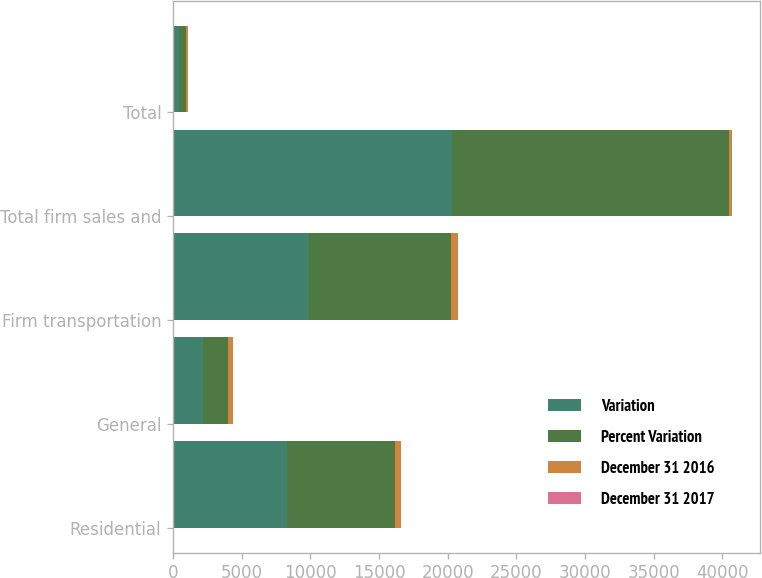Convert chart. <chart><loc_0><loc_0><loc_500><loc_500><stacked_bar_chart><ecel><fcel>Residential<fcel>General<fcel>Firm transportation<fcel>Total firm sales and<fcel>Total<nl><fcel>Variation<fcel>8296<fcel>2184<fcel>9873<fcel>20353<fcel>466<nl><fcel>Percent Variation<fcel>7872<fcel>1851<fcel>10381<fcel>20104<fcel>466<nl><fcel>December 31 2016<fcel>424<fcel>333<fcel>508<fcel>249<fcel>187<nl><fcel>December 31 2017<fcel>5.4<fcel>18<fcel>4.9<fcel>1.2<fcel>0.8<nl></chart> 